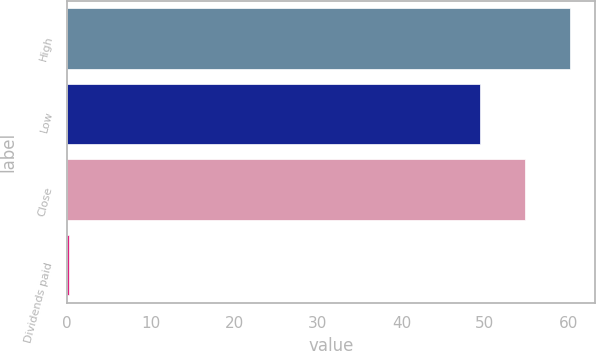Convert chart. <chart><loc_0><loc_0><loc_500><loc_500><bar_chart><fcel>High<fcel>Low<fcel>Close<fcel>Dividends paid<nl><fcel>60.19<fcel>49.39<fcel>54.79<fcel>0.23<nl></chart> 